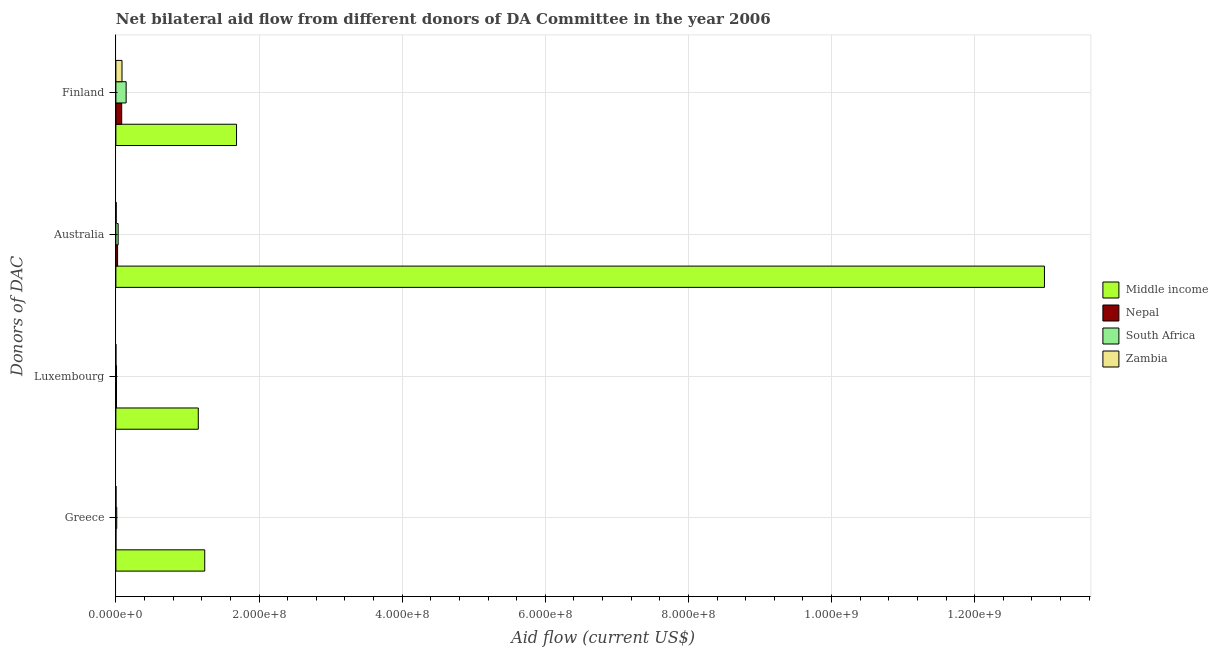How many different coloured bars are there?
Provide a succinct answer. 4. How many groups of bars are there?
Make the answer very short. 4. Are the number of bars per tick equal to the number of legend labels?
Offer a very short reply. Yes. Are the number of bars on each tick of the Y-axis equal?
Make the answer very short. Yes. What is the amount of aid given by greece in Nepal?
Keep it short and to the point. 2.00e+04. Across all countries, what is the maximum amount of aid given by greece?
Provide a succinct answer. 1.24e+08. Across all countries, what is the minimum amount of aid given by luxembourg?
Offer a terse response. 10000. In which country was the amount of aid given by australia minimum?
Provide a short and direct response. Zambia. What is the total amount of aid given by luxembourg in the graph?
Offer a terse response. 1.17e+08. What is the difference between the amount of aid given by australia in Nepal and that in Middle income?
Provide a succinct answer. -1.30e+09. What is the difference between the amount of aid given by australia in Nepal and the amount of aid given by greece in Middle income?
Ensure brevity in your answer.  -1.22e+08. What is the average amount of aid given by greece per country?
Ensure brevity in your answer.  3.14e+07. What is the difference between the amount of aid given by australia and amount of aid given by finland in Zambia?
Offer a very short reply. -8.05e+06. What is the ratio of the amount of aid given by finland in South Africa to that in Middle income?
Your answer should be very brief. 0.08. Is the amount of aid given by luxembourg in Zambia less than that in Middle income?
Make the answer very short. Yes. What is the difference between the highest and the second highest amount of aid given by australia?
Make the answer very short. 1.29e+09. What is the difference between the highest and the lowest amount of aid given by finland?
Your response must be concise. 1.60e+08. In how many countries, is the amount of aid given by finland greater than the average amount of aid given by finland taken over all countries?
Ensure brevity in your answer.  1. Is the sum of the amount of aid given by australia in Zambia and Middle income greater than the maximum amount of aid given by greece across all countries?
Ensure brevity in your answer.  Yes. What does the 3rd bar from the top in Finland represents?
Provide a short and direct response. Nepal. Is it the case that in every country, the sum of the amount of aid given by greece and amount of aid given by luxembourg is greater than the amount of aid given by australia?
Give a very brief answer. No. How many bars are there?
Give a very brief answer. 16. How many countries are there in the graph?
Make the answer very short. 4. Does the graph contain any zero values?
Ensure brevity in your answer.  No. What is the title of the graph?
Offer a very short reply. Net bilateral aid flow from different donors of DA Committee in the year 2006. What is the label or title of the Y-axis?
Provide a short and direct response. Donors of DAC. What is the Aid flow (current US$) of Middle income in Greece?
Provide a short and direct response. 1.24e+08. What is the Aid flow (current US$) in South Africa in Greece?
Provide a succinct answer. 1.17e+06. What is the Aid flow (current US$) in Middle income in Luxembourg?
Keep it short and to the point. 1.15e+08. What is the Aid flow (current US$) in Nepal in Luxembourg?
Your answer should be very brief. 8.50e+05. What is the Aid flow (current US$) in South Africa in Luxembourg?
Your answer should be compact. 8.70e+05. What is the Aid flow (current US$) in Middle income in Australia?
Keep it short and to the point. 1.30e+09. What is the Aid flow (current US$) in Nepal in Australia?
Offer a very short reply. 2.39e+06. What is the Aid flow (current US$) in South Africa in Australia?
Your answer should be compact. 3.16e+06. What is the Aid flow (current US$) in Middle income in Finland?
Give a very brief answer. 1.69e+08. What is the Aid flow (current US$) in Nepal in Finland?
Ensure brevity in your answer.  8.12e+06. What is the Aid flow (current US$) of South Africa in Finland?
Offer a very short reply. 1.43e+07. What is the Aid flow (current US$) of Zambia in Finland?
Your answer should be compact. 8.54e+06. Across all Donors of DAC, what is the maximum Aid flow (current US$) in Middle income?
Provide a short and direct response. 1.30e+09. Across all Donors of DAC, what is the maximum Aid flow (current US$) of Nepal?
Provide a succinct answer. 8.12e+06. Across all Donors of DAC, what is the maximum Aid flow (current US$) of South Africa?
Your answer should be very brief. 1.43e+07. Across all Donors of DAC, what is the maximum Aid flow (current US$) of Zambia?
Offer a terse response. 8.54e+06. Across all Donors of DAC, what is the minimum Aid flow (current US$) of Middle income?
Give a very brief answer. 1.15e+08. Across all Donors of DAC, what is the minimum Aid flow (current US$) of South Africa?
Provide a short and direct response. 8.70e+05. What is the total Aid flow (current US$) of Middle income in the graph?
Provide a short and direct response. 1.71e+09. What is the total Aid flow (current US$) in Nepal in the graph?
Provide a short and direct response. 1.14e+07. What is the total Aid flow (current US$) in South Africa in the graph?
Make the answer very short. 1.95e+07. What is the total Aid flow (current US$) of Zambia in the graph?
Ensure brevity in your answer.  9.20e+06. What is the difference between the Aid flow (current US$) in Middle income in Greece and that in Luxembourg?
Your answer should be very brief. 9.02e+06. What is the difference between the Aid flow (current US$) in Nepal in Greece and that in Luxembourg?
Provide a succinct answer. -8.30e+05. What is the difference between the Aid flow (current US$) of Middle income in Greece and that in Australia?
Give a very brief answer. -1.17e+09. What is the difference between the Aid flow (current US$) of Nepal in Greece and that in Australia?
Ensure brevity in your answer.  -2.37e+06. What is the difference between the Aid flow (current US$) in South Africa in Greece and that in Australia?
Offer a very short reply. -1.99e+06. What is the difference between the Aid flow (current US$) of Zambia in Greece and that in Australia?
Offer a terse response. -3.30e+05. What is the difference between the Aid flow (current US$) in Middle income in Greece and that in Finland?
Your answer should be compact. -4.44e+07. What is the difference between the Aid flow (current US$) of Nepal in Greece and that in Finland?
Provide a succinct answer. -8.10e+06. What is the difference between the Aid flow (current US$) in South Africa in Greece and that in Finland?
Your response must be concise. -1.32e+07. What is the difference between the Aid flow (current US$) of Zambia in Greece and that in Finland?
Give a very brief answer. -8.38e+06. What is the difference between the Aid flow (current US$) of Middle income in Luxembourg and that in Australia?
Provide a succinct answer. -1.18e+09. What is the difference between the Aid flow (current US$) of Nepal in Luxembourg and that in Australia?
Offer a terse response. -1.54e+06. What is the difference between the Aid flow (current US$) of South Africa in Luxembourg and that in Australia?
Your response must be concise. -2.29e+06. What is the difference between the Aid flow (current US$) of Zambia in Luxembourg and that in Australia?
Give a very brief answer. -4.80e+05. What is the difference between the Aid flow (current US$) of Middle income in Luxembourg and that in Finland?
Offer a terse response. -5.34e+07. What is the difference between the Aid flow (current US$) in Nepal in Luxembourg and that in Finland?
Provide a succinct answer. -7.27e+06. What is the difference between the Aid flow (current US$) in South Africa in Luxembourg and that in Finland?
Keep it short and to the point. -1.35e+07. What is the difference between the Aid flow (current US$) of Zambia in Luxembourg and that in Finland?
Your answer should be compact. -8.53e+06. What is the difference between the Aid flow (current US$) of Middle income in Australia and that in Finland?
Your response must be concise. 1.13e+09. What is the difference between the Aid flow (current US$) of Nepal in Australia and that in Finland?
Your answer should be very brief. -5.73e+06. What is the difference between the Aid flow (current US$) of South Africa in Australia and that in Finland?
Offer a terse response. -1.12e+07. What is the difference between the Aid flow (current US$) in Zambia in Australia and that in Finland?
Keep it short and to the point. -8.05e+06. What is the difference between the Aid flow (current US$) in Middle income in Greece and the Aid flow (current US$) in Nepal in Luxembourg?
Offer a very short reply. 1.23e+08. What is the difference between the Aid flow (current US$) in Middle income in Greece and the Aid flow (current US$) in South Africa in Luxembourg?
Your answer should be very brief. 1.23e+08. What is the difference between the Aid flow (current US$) of Middle income in Greece and the Aid flow (current US$) of Zambia in Luxembourg?
Ensure brevity in your answer.  1.24e+08. What is the difference between the Aid flow (current US$) of Nepal in Greece and the Aid flow (current US$) of South Africa in Luxembourg?
Your answer should be very brief. -8.50e+05. What is the difference between the Aid flow (current US$) of Nepal in Greece and the Aid flow (current US$) of Zambia in Luxembourg?
Give a very brief answer. 10000. What is the difference between the Aid flow (current US$) in South Africa in Greece and the Aid flow (current US$) in Zambia in Luxembourg?
Ensure brevity in your answer.  1.16e+06. What is the difference between the Aid flow (current US$) of Middle income in Greece and the Aid flow (current US$) of Nepal in Australia?
Offer a terse response. 1.22e+08. What is the difference between the Aid flow (current US$) in Middle income in Greece and the Aid flow (current US$) in South Africa in Australia?
Provide a succinct answer. 1.21e+08. What is the difference between the Aid flow (current US$) in Middle income in Greece and the Aid flow (current US$) in Zambia in Australia?
Offer a very short reply. 1.24e+08. What is the difference between the Aid flow (current US$) in Nepal in Greece and the Aid flow (current US$) in South Africa in Australia?
Give a very brief answer. -3.14e+06. What is the difference between the Aid flow (current US$) in Nepal in Greece and the Aid flow (current US$) in Zambia in Australia?
Your response must be concise. -4.70e+05. What is the difference between the Aid flow (current US$) of South Africa in Greece and the Aid flow (current US$) of Zambia in Australia?
Your answer should be very brief. 6.80e+05. What is the difference between the Aid flow (current US$) in Middle income in Greece and the Aid flow (current US$) in Nepal in Finland?
Ensure brevity in your answer.  1.16e+08. What is the difference between the Aid flow (current US$) of Middle income in Greece and the Aid flow (current US$) of South Africa in Finland?
Make the answer very short. 1.10e+08. What is the difference between the Aid flow (current US$) of Middle income in Greece and the Aid flow (current US$) of Zambia in Finland?
Make the answer very short. 1.16e+08. What is the difference between the Aid flow (current US$) in Nepal in Greece and the Aid flow (current US$) in South Africa in Finland?
Give a very brief answer. -1.43e+07. What is the difference between the Aid flow (current US$) in Nepal in Greece and the Aid flow (current US$) in Zambia in Finland?
Offer a terse response. -8.52e+06. What is the difference between the Aid flow (current US$) of South Africa in Greece and the Aid flow (current US$) of Zambia in Finland?
Provide a short and direct response. -7.37e+06. What is the difference between the Aid flow (current US$) in Middle income in Luxembourg and the Aid flow (current US$) in Nepal in Australia?
Make the answer very short. 1.13e+08. What is the difference between the Aid flow (current US$) in Middle income in Luxembourg and the Aid flow (current US$) in South Africa in Australia?
Offer a terse response. 1.12e+08. What is the difference between the Aid flow (current US$) in Middle income in Luxembourg and the Aid flow (current US$) in Zambia in Australia?
Provide a short and direct response. 1.15e+08. What is the difference between the Aid flow (current US$) in Nepal in Luxembourg and the Aid flow (current US$) in South Africa in Australia?
Offer a terse response. -2.31e+06. What is the difference between the Aid flow (current US$) in Nepal in Luxembourg and the Aid flow (current US$) in Zambia in Australia?
Your answer should be compact. 3.60e+05. What is the difference between the Aid flow (current US$) of Middle income in Luxembourg and the Aid flow (current US$) of Nepal in Finland?
Offer a terse response. 1.07e+08. What is the difference between the Aid flow (current US$) of Middle income in Luxembourg and the Aid flow (current US$) of South Africa in Finland?
Keep it short and to the point. 1.01e+08. What is the difference between the Aid flow (current US$) in Middle income in Luxembourg and the Aid flow (current US$) in Zambia in Finland?
Provide a short and direct response. 1.07e+08. What is the difference between the Aid flow (current US$) of Nepal in Luxembourg and the Aid flow (current US$) of South Africa in Finland?
Provide a short and direct response. -1.35e+07. What is the difference between the Aid flow (current US$) in Nepal in Luxembourg and the Aid flow (current US$) in Zambia in Finland?
Offer a very short reply. -7.69e+06. What is the difference between the Aid flow (current US$) in South Africa in Luxembourg and the Aid flow (current US$) in Zambia in Finland?
Provide a short and direct response. -7.67e+06. What is the difference between the Aid flow (current US$) of Middle income in Australia and the Aid flow (current US$) of Nepal in Finland?
Offer a terse response. 1.29e+09. What is the difference between the Aid flow (current US$) in Middle income in Australia and the Aid flow (current US$) in South Africa in Finland?
Ensure brevity in your answer.  1.28e+09. What is the difference between the Aid flow (current US$) in Middle income in Australia and the Aid flow (current US$) in Zambia in Finland?
Provide a succinct answer. 1.29e+09. What is the difference between the Aid flow (current US$) in Nepal in Australia and the Aid flow (current US$) in South Africa in Finland?
Your answer should be very brief. -1.19e+07. What is the difference between the Aid flow (current US$) in Nepal in Australia and the Aid flow (current US$) in Zambia in Finland?
Offer a very short reply. -6.15e+06. What is the difference between the Aid flow (current US$) in South Africa in Australia and the Aid flow (current US$) in Zambia in Finland?
Your response must be concise. -5.38e+06. What is the average Aid flow (current US$) in Middle income per Donors of DAC?
Offer a very short reply. 4.26e+08. What is the average Aid flow (current US$) of Nepal per Donors of DAC?
Your answer should be very brief. 2.84e+06. What is the average Aid flow (current US$) of South Africa per Donors of DAC?
Offer a terse response. 4.88e+06. What is the average Aid flow (current US$) of Zambia per Donors of DAC?
Offer a terse response. 2.30e+06. What is the difference between the Aid flow (current US$) in Middle income and Aid flow (current US$) in Nepal in Greece?
Make the answer very short. 1.24e+08. What is the difference between the Aid flow (current US$) in Middle income and Aid flow (current US$) in South Africa in Greece?
Keep it short and to the point. 1.23e+08. What is the difference between the Aid flow (current US$) in Middle income and Aid flow (current US$) in Zambia in Greece?
Provide a succinct answer. 1.24e+08. What is the difference between the Aid flow (current US$) of Nepal and Aid flow (current US$) of South Africa in Greece?
Ensure brevity in your answer.  -1.15e+06. What is the difference between the Aid flow (current US$) of South Africa and Aid flow (current US$) of Zambia in Greece?
Ensure brevity in your answer.  1.01e+06. What is the difference between the Aid flow (current US$) of Middle income and Aid flow (current US$) of Nepal in Luxembourg?
Give a very brief answer. 1.14e+08. What is the difference between the Aid flow (current US$) of Middle income and Aid flow (current US$) of South Africa in Luxembourg?
Keep it short and to the point. 1.14e+08. What is the difference between the Aid flow (current US$) in Middle income and Aid flow (current US$) in Zambia in Luxembourg?
Provide a short and direct response. 1.15e+08. What is the difference between the Aid flow (current US$) of Nepal and Aid flow (current US$) of Zambia in Luxembourg?
Make the answer very short. 8.40e+05. What is the difference between the Aid flow (current US$) in South Africa and Aid flow (current US$) in Zambia in Luxembourg?
Offer a terse response. 8.60e+05. What is the difference between the Aid flow (current US$) in Middle income and Aid flow (current US$) in Nepal in Australia?
Offer a terse response. 1.30e+09. What is the difference between the Aid flow (current US$) of Middle income and Aid flow (current US$) of South Africa in Australia?
Provide a short and direct response. 1.29e+09. What is the difference between the Aid flow (current US$) in Middle income and Aid flow (current US$) in Zambia in Australia?
Ensure brevity in your answer.  1.30e+09. What is the difference between the Aid flow (current US$) in Nepal and Aid flow (current US$) in South Africa in Australia?
Provide a succinct answer. -7.70e+05. What is the difference between the Aid flow (current US$) of Nepal and Aid flow (current US$) of Zambia in Australia?
Offer a terse response. 1.90e+06. What is the difference between the Aid flow (current US$) in South Africa and Aid flow (current US$) in Zambia in Australia?
Your answer should be compact. 2.67e+06. What is the difference between the Aid flow (current US$) in Middle income and Aid flow (current US$) in Nepal in Finland?
Your response must be concise. 1.60e+08. What is the difference between the Aid flow (current US$) of Middle income and Aid flow (current US$) of South Africa in Finland?
Keep it short and to the point. 1.54e+08. What is the difference between the Aid flow (current US$) in Middle income and Aid flow (current US$) in Zambia in Finland?
Provide a short and direct response. 1.60e+08. What is the difference between the Aid flow (current US$) of Nepal and Aid flow (current US$) of South Africa in Finland?
Your answer should be very brief. -6.21e+06. What is the difference between the Aid flow (current US$) in Nepal and Aid flow (current US$) in Zambia in Finland?
Provide a succinct answer. -4.20e+05. What is the difference between the Aid flow (current US$) of South Africa and Aid flow (current US$) of Zambia in Finland?
Offer a very short reply. 5.79e+06. What is the ratio of the Aid flow (current US$) in Middle income in Greece to that in Luxembourg?
Your answer should be compact. 1.08. What is the ratio of the Aid flow (current US$) of Nepal in Greece to that in Luxembourg?
Offer a very short reply. 0.02. What is the ratio of the Aid flow (current US$) in South Africa in Greece to that in Luxembourg?
Ensure brevity in your answer.  1.34. What is the ratio of the Aid flow (current US$) in Middle income in Greece to that in Australia?
Ensure brevity in your answer.  0.1. What is the ratio of the Aid flow (current US$) in Nepal in Greece to that in Australia?
Give a very brief answer. 0.01. What is the ratio of the Aid flow (current US$) of South Africa in Greece to that in Australia?
Offer a terse response. 0.37. What is the ratio of the Aid flow (current US$) in Zambia in Greece to that in Australia?
Give a very brief answer. 0.33. What is the ratio of the Aid flow (current US$) of Middle income in Greece to that in Finland?
Ensure brevity in your answer.  0.74. What is the ratio of the Aid flow (current US$) of Nepal in Greece to that in Finland?
Keep it short and to the point. 0. What is the ratio of the Aid flow (current US$) in South Africa in Greece to that in Finland?
Offer a terse response. 0.08. What is the ratio of the Aid flow (current US$) in Zambia in Greece to that in Finland?
Provide a succinct answer. 0.02. What is the ratio of the Aid flow (current US$) of Middle income in Luxembourg to that in Australia?
Your answer should be compact. 0.09. What is the ratio of the Aid flow (current US$) in Nepal in Luxembourg to that in Australia?
Your response must be concise. 0.36. What is the ratio of the Aid flow (current US$) of South Africa in Luxembourg to that in Australia?
Make the answer very short. 0.28. What is the ratio of the Aid flow (current US$) of Zambia in Luxembourg to that in Australia?
Ensure brevity in your answer.  0.02. What is the ratio of the Aid flow (current US$) of Middle income in Luxembourg to that in Finland?
Provide a succinct answer. 0.68. What is the ratio of the Aid flow (current US$) in Nepal in Luxembourg to that in Finland?
Your answer should be very brief. 0.1. What is the ratio of the Aid flow (current US$) in South Africa in Luxembourg to that in Finland?
Provide a short and direct response. 0.06. What is the ratio of the Aid flow (current US$) of Zambia in Luxembourg to that in Finland?
Provide a succinct answer. 0. What is the ratio of the Aid flow (current US$) of Middle income in Australia to that in Finland?
Provide a short and direct response. 7.7. What is the ratio of the Aid flow (current US$) of Nepal in Australia to that in Finland?
Provide a short and direct response. 0.29. What is the ratio of the Aid flow (current US$) in South Africa in Australia to that in Finland?
Your response must be concise. 0.22. What is the ratio of the Aid flow (current US$) of Zambia in Australia to that in Finland?
Offer a terse response. 0.06. What is the difference between the highest and the second highest Aid flow (current US$) in Middle income?
Provide a short and direct response. 1.13e+09. What is the difference between the highest and the second highest Aid flow (current US$) of Nepal?
Provide a short and direct response. 5.73e+06. What is the difference between the highest and the second highest Aid flow (current US$) in South Africa?
Your answer should be compact. 1.12e+07. What is the difference between the highest and the second highest Aid flow (current US$) in Zambia?
Your response must be concise. 8.05e+06. What is the difference between the highest and the lowest Aid flow (current US$) in Middle income?
Provide a succinct answer. 1.18e+09. What is the difference between the highest and the lowest Aid flow (current US$) in Nepal?
Offer a terse response. 8.10e+06. What is the difference between the highest and the lowest Aid flow (current US$) in South Africa?
Make the answer very short. 1.35e+07. What is the difference between the highest and the lowest Aid flow (current US$) of Zambia?
Provide a succinct answer. 8.53e+06. 